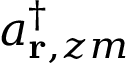Convert formula to latex. <formula><loc_0><loc_0><loc_500><loc_500>a _ { { r } , z m } ^ { \dagger }</formula> 